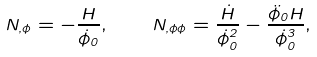<formula> <loc_0><loc_0><loc_500><loc_500>N _ { , \phi } = - \frac { H } { \dot { \phi } _ { 0 } } , \quad N _ { , \phi \phi } = \frac { \dot { H } } { \dot { \phi } _ { 0 } ^ { 2 } } - \frac { \ddot { \phi } _ { 0 } H } { \dot { \phi } _ { 0 } ^ { 3 } } ,</formula> 